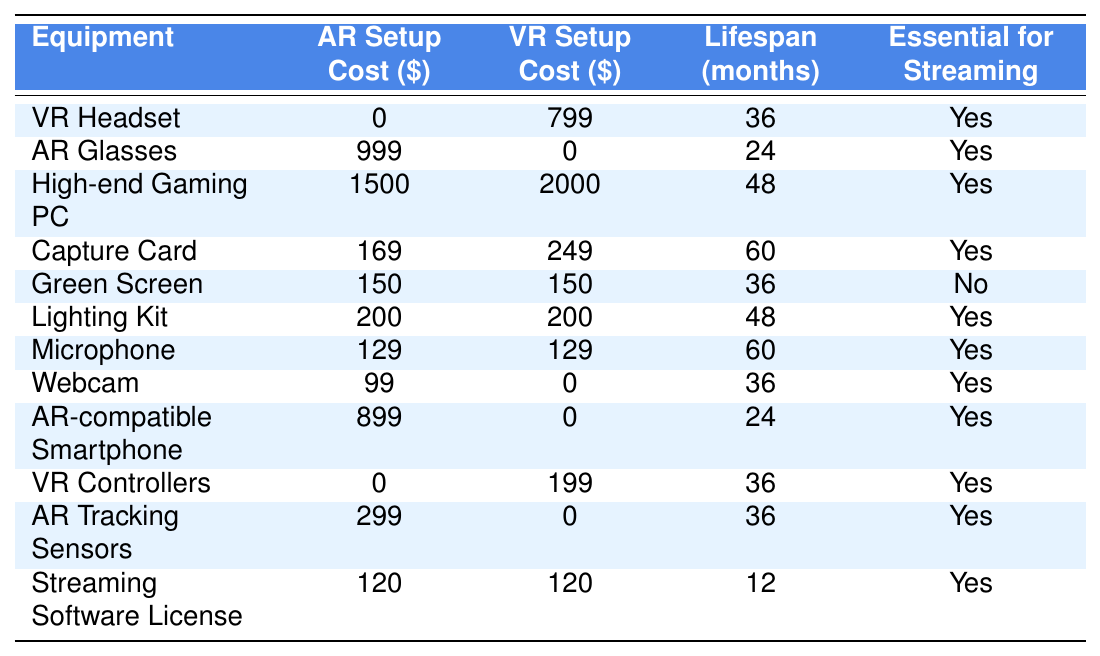What is the cost of the VR Headset? The table lists the VR setup cost for the VR Headset as $799.
Answer: 799 What is the lifespan of the AR Glasses? The table shows that the lifespan of the AR Glasses is 24 months.
Answer: 24 months Which equipment has the highest initial cost for an AR setup? The table indicates that the High-end Gaming PC has the highest cost at $1500 for AR setups.
Answer: 1500 Is the Green Screen essential for streaming? According to the table, the Green Screen is marked as "No," indicating it is not essential for streaming.
Answer: No What is the total cost of all AR setup equipment? The total cost of all AR setup equipment is calculated by adding all values in the "AR Setup Cost" column: 0 + 999 + 1500 + 169 + 150 + 200 + 129 + 99 + 899 + 0 + 299 + 120 = 3624.
Answer: 3624 How much more expensive is a High-end Gaming PC for VR compared to AR? The cost of a High-end Gaming PC for VR is $2000 and for AR is $1500. The difference is $2000 - $1500 = $500.
Answer: 500 Which equipment is not essential for streaming but has a cost? The table shows that the Green Screen is not essential for streaming but has a cost of $150.
Answer: Green Screen On average, how much does each piece of equipment cost for AR setups? To find the average, sum all AR setup costs (3624) and divide by the number of equipment types (12): 3624 / 12 = 302.
Answer: 302 Which AR equipment has a shorter lifespan compared to VR equipment? By comparing lifespans in the table, AR Glasses at 24 months and AR-compatible Smartphone at 24 months have shorter lifespans than multiple VR equipment; however, the common equipment like Webcam has the same lifespan of 36 months in VR.
Answer: AR Glasses and AR-compatible Smartphone How many pieces of equipment listed have a lifespan of 36 months or more for both AR and VR? Checking the table, the pieces of equipment with at least 36 months lifespan are: VR Headset (36), High-end Gaming PC (48), Capture Card (60), Lighting Kit (48), Microphone (60), Webcam (36), VR Controllers (36), AR Tracking Sensors (36). This totals 8 pieces of equipment in both setups combined.
Answer: 8 